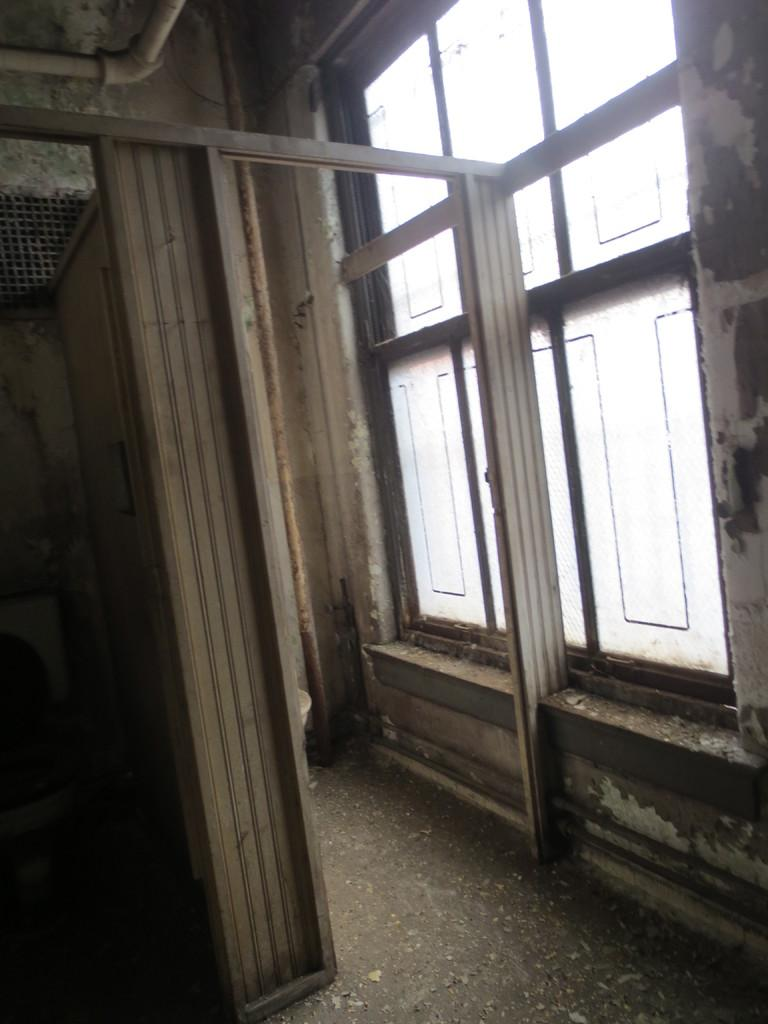What type of location is depicted in the image? The image shows an inside view of a building. What structural elements can be seen in the image? There is a wall, a window, a pole, a door, and a pipeline in the image. Can you see any cherries hanging from the ceiling in the image? There are no cherries present in the image. Is there a letter addressed to someone on the wall in the image? There is no letter visible on the wall in the image. 